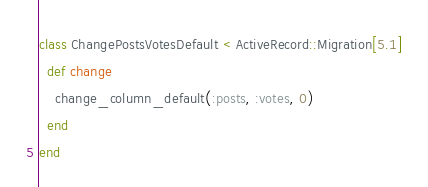<code> <loc_0><loc_0><loc_500><loc_500><_Ruby_>class ChangePostsVotesDefault < ActiveRecord::Migration[5.1]
  def change
    change_column_default(:posts, :votes, 0)
  end
end
</code> 